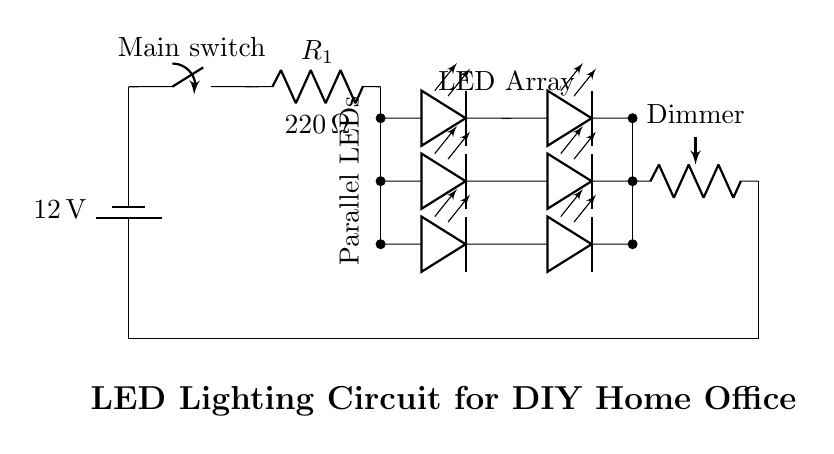What is the voltage of the power supply? The voltage is 12 volts, which is specified next to the battery symbol in the circuit diagram.
Answer: 12 volts What is the purpose of the resistor labeled R1? The resistor R1 is used for current limiting, which is indicated in its label, ensuring that the current flowing to the LED array stays within safe levels to prevent damage.
Answer: Current limiting How many LEDs are in the array? There are six LEDs in total, as seen in the diagram, grouped into three parallel pairs.
Answer: Six What is the resistance value of the current limiting resistor? The resistance value of R1 is 220 ohms, which is directly stated in the circuit next to the resistor symbol.
Answer: 220 ohms How is the LED array configured? The LED array is configured in parallel, as indicated by the connections where each LED's anode connects to the same voltage point, allowing for independent operation.
Answer: Parallel What component allows for adjusting the brightness of the LED lights? The component is a dimmer potentiometer, labeled as "Dimmer" in the circuit, which alters current flow to adjust brightness.
Answer: Dimmer What is the function of the main switch in the circuit? The main switch controls the on/off state of the circuit, allowing the user to disconnect power from all components when turned off.
Answer: Control power 